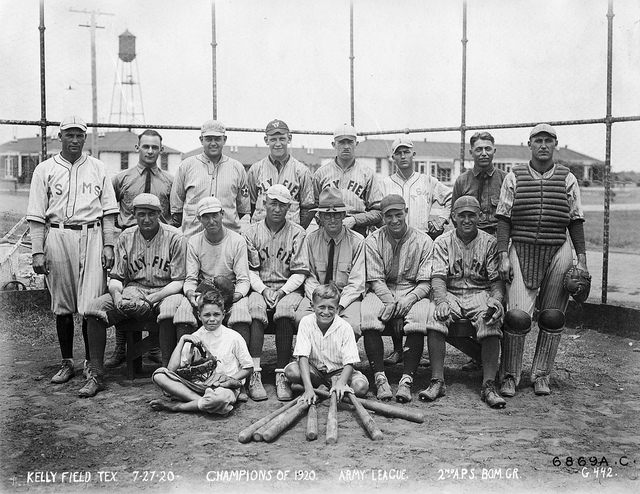<image>What team do these men play on? It is ambiguous what team these men play on. They could possibly be part of the 'kelly field' team or a 'baseball' team. What team do these men play on? I don't know what team these men play on. It could be baseball or Kelly Field. 